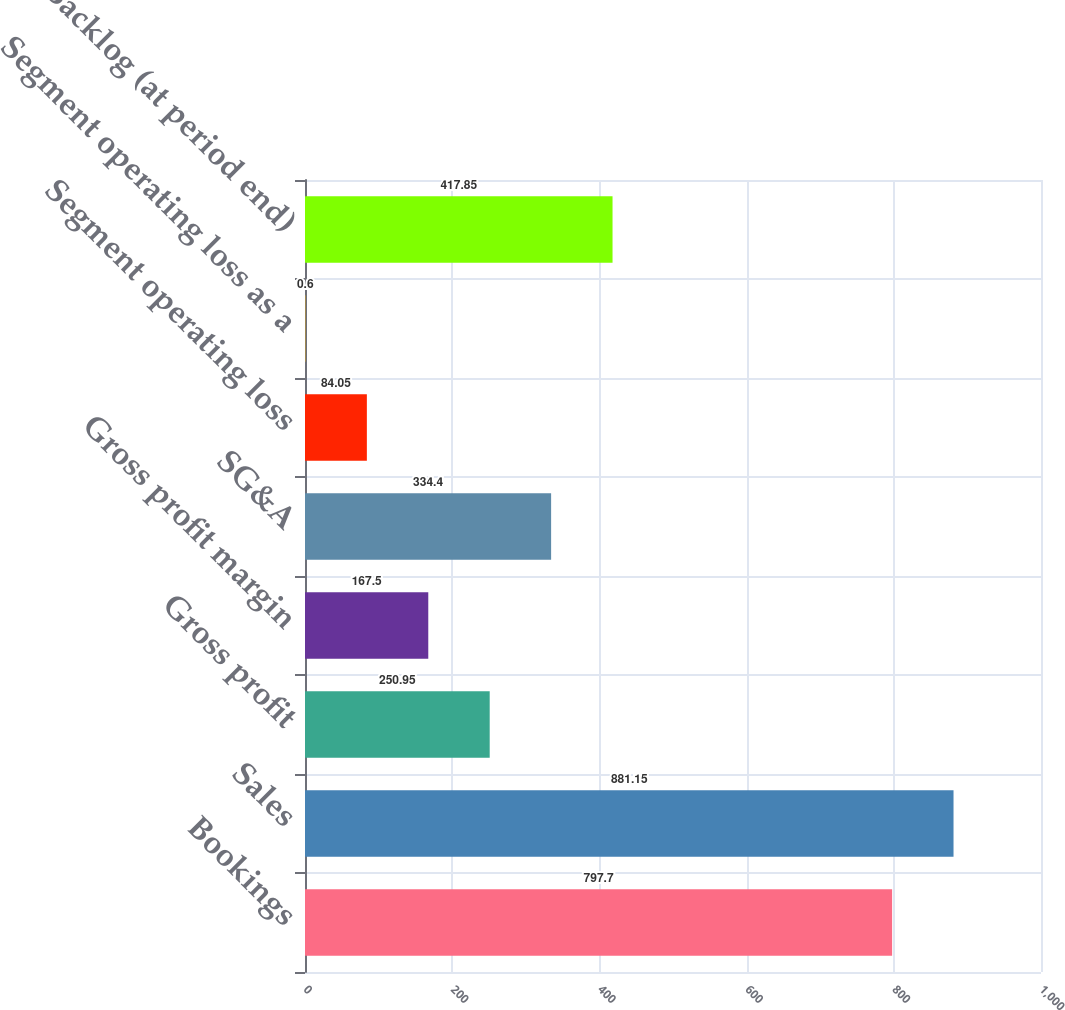Convert chart to OTSL. <chart><loc_0><loc_0><loc_500><loc_500><bar_chart><fcel>Bookings<fcel>Sales<fcel>Gross profit<fcel>Gross profit margin<fcel>SG&A<fcel>Segment operating loss<fcel>Segment operating loss as a<fcel>Backlog (at period end)<nl><fcel>797.7<fcel>881.15<fcel>250.95<fcel>167.5<fcel>334.4<fcel>84.05<fcel>0.6<fcel>417.85<nl></chart> 